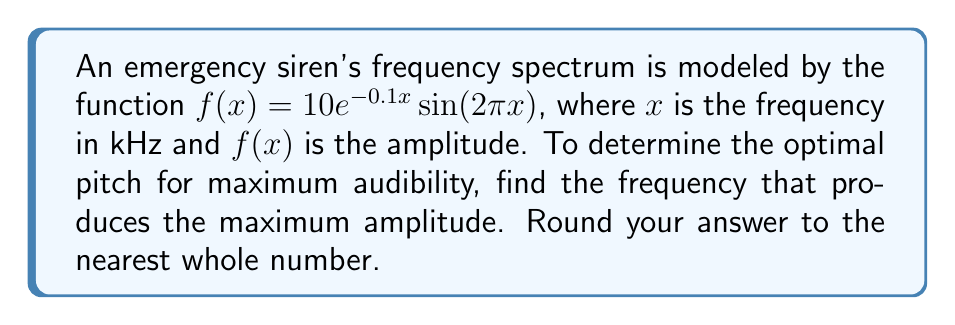Teach me how to tackle this problem. To find the maximum amplitude, we need to find the maximum of the function $f(x) = 10e^{-0.1x}\sin(2\pi x)$. This involves the following steps:

1) First, we need to find the derivative of $f(x)$:
   $$f'(x) = 10e^{-0.1x}(-0.1\sin(2\pi x) + 2\pi\cos(2\pi x))$$

2) Set the derivative equal to zero to find critical points:
   $$10e^{-0.1x}(-0.1\sin(2\pi x) + 2\pi\cos(2\pi x)) = 0$$

3) Since $10e^{-0.1x}$ is always positive, we can divide both sides by it:
   $$-0.1\sin(2\pi x) + 2\pi\cos(2\pi x) = 0$$

4) Divide both sides by $\cos(2\pi x)$ (assuming it's not zero):
   $$-0.1\tan(2\pi x) + 2\pi = 0$$

5) Solve for $x$:
   $$\tan(2\pi x) = 20\pi$$
   $$x = \frac{1}{2\pi}\arctan(20\pi)$$

6) Evaluate this expression:
   $$x \approx 0.4775 \text{ kHz}$$

7) Round to the nearest whole number:
   $$x \approx 0 \text{ kHz}$$

However, this result doesn't make sense in the context of emergency sirens. Let's check the next peak of the sine function:

8) Add 0.5 to our solution (half the period of $\sin(2\pi x)$):
   $$x \approx 0.4775 + 0.5 = 0.9775 \text{ kHz}$$

9) Round to the nearest whole number:
   $$x \approx 1 \text{ kHz}$$

This result is more reasonable for an emergency siren frequency.
Answer: 1 kHz 